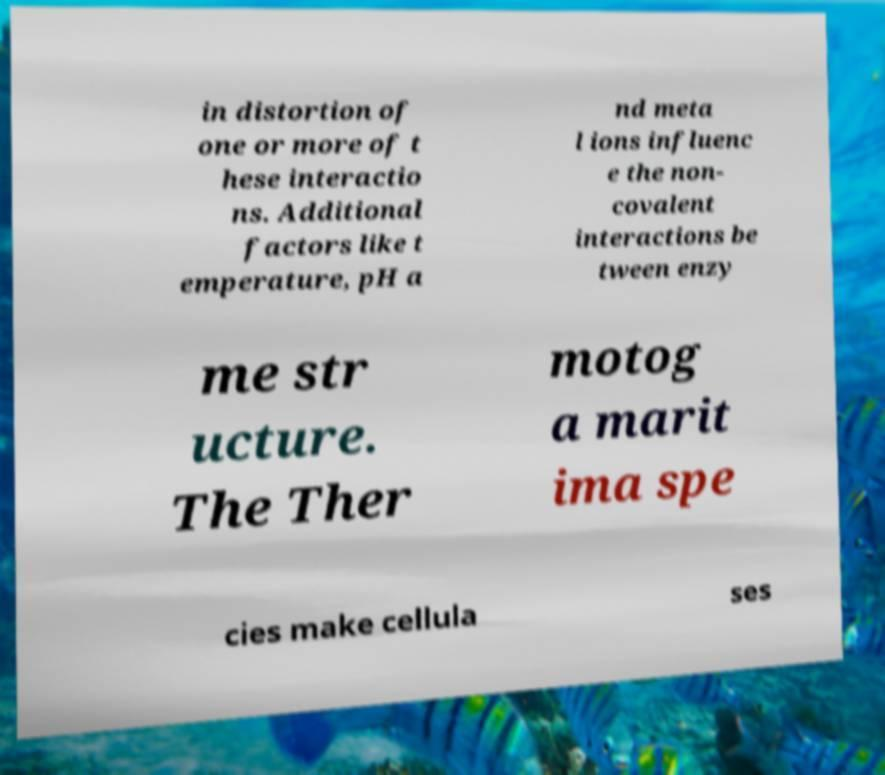For documentation purposes, I need the text within this image transcribed. Could you provide that? in distortion of one or more of t hese interactio ns. Additional factors like t emperature, pH a nd meta l ions influenc e the non- covalent interactions be tween enzy me str ucture. The Ther motog a marit ima spe cies make cellula ses 